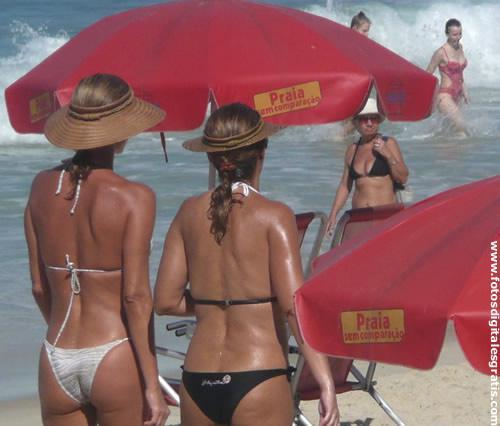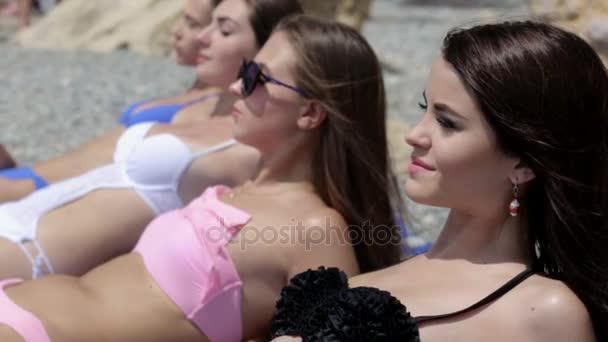The first image is the image on the left, the second image is the image on the right. For the images shown, is this caption "There is a total of six women in bikinis." true? Answer yes or no. No. The first image is the image on the left, the second image is the image on the right. Examine the images to the left and right. Is the description "Three forward-facing bikini models are in the left image, and three rear-facing bikini models are in the right image." accurate? Answer yes or no. No. 